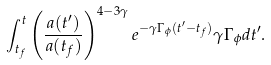Convert formula to latex. <formula><loc_0><loc_0><loc_500><loc_500>\int ^ { t } _ { t _ { f } } \left ( \frac { a ( t ^ { \prime } ) } { a ( t _ { f } ) } \right ) ^ { 4 - 3 \gamma } e ^ { - \gamma \Gamma _ { \phi } ( t ^ { \prime } - t _ { f } ) } \gamma \Gamma _ { \phi } d t ^ { \prime } .</formula> 